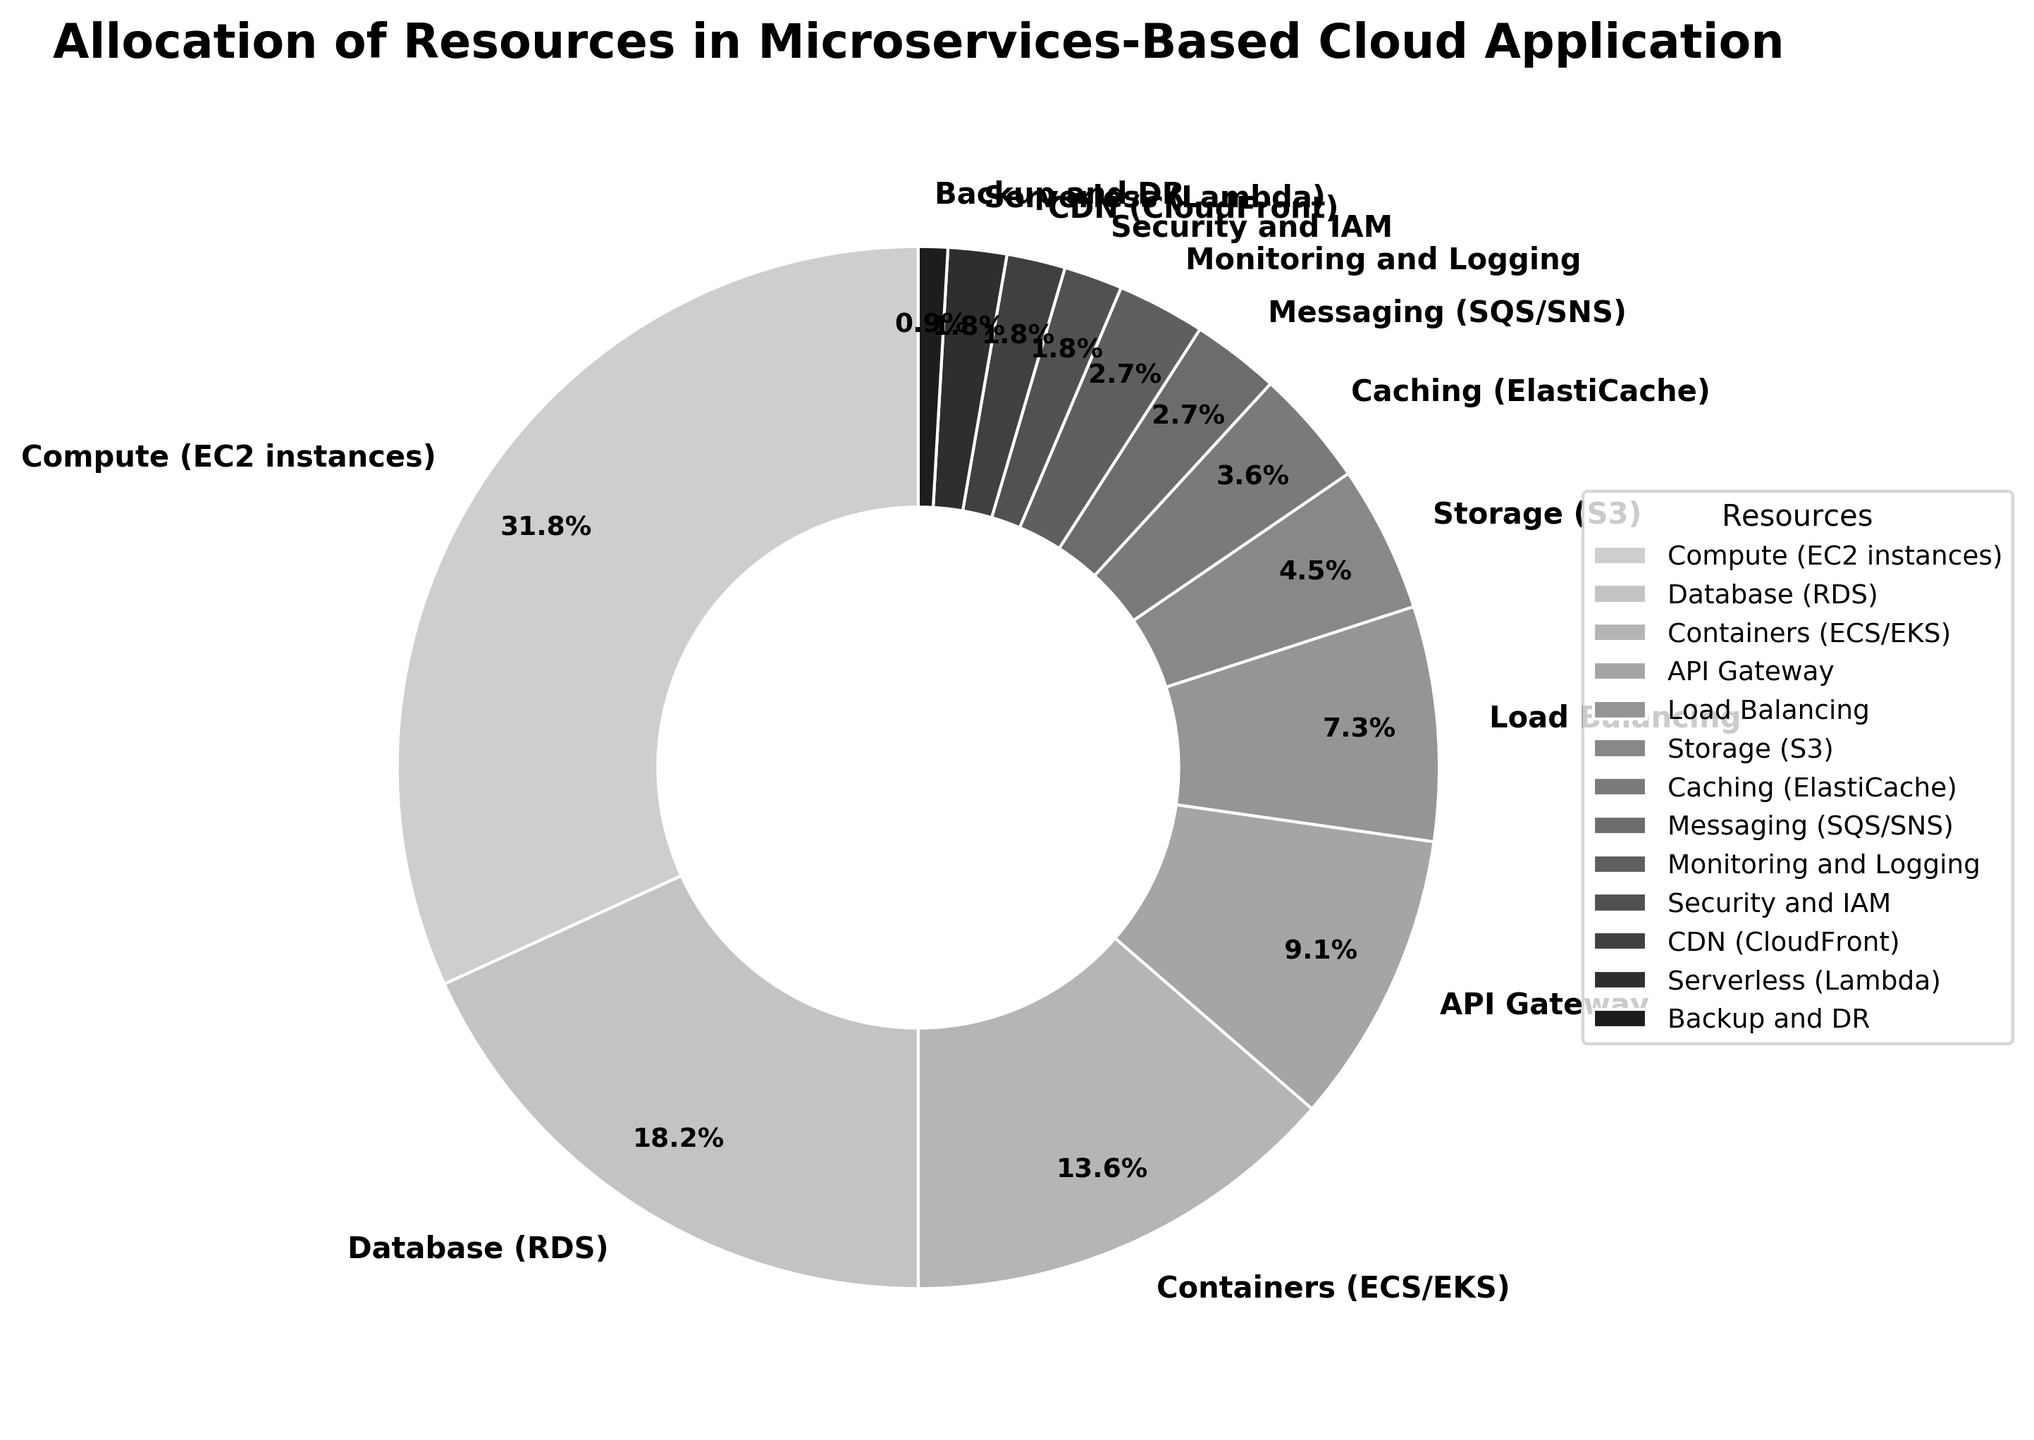What resource consumes the highest percentage of the total allocation? The pie chart shows the allocation of resources with labels indicating percentages. The segment labeled "Compute (EC2 instances)" shows the highest percentage at 35%.
Answer: Compute (EC2 instances) Which two resources together make up 20% of the allocation? To find the resources that together make up 20% of the allocation, look for individual segments that add up to 20%. Both "Messaging (SQS/SNS)" at 3% and "Monitoring and Logging" at 3% add up to 6%. Including "Caching (ElastiCache)" at 4% gives us 10%. Adding "Storage (S3)" at 5% gives 15%, and finally adding the "API Gateway" at 10% makes it 25%. Therefore, "Database (RDS)" at 20% alone contributes to 20%.
Answer: Database (RDS) How much more does Compute (EC2 instances) consume compared to Containers (ECS/EKS)? Compute (EC2 instances) consumes 35%, and Containers (ECS/EKS) consume 15%. The difference is calculated by subtracting 15% from 35%, resulting in 20%.
Answer: 20% Which resource contributes the least to the allocation? The pie chart shows various percentages for each resource, with the smallest segment labeled "Backup and DR" at 1%.
Answer: Backup and DR What is the combined percentage of Load Balancing and API Gateway? Locate the segments for Load Balancing (8%) and API Gateway (10%) and sum these percentages: 8% + 10% equals 18%.
Answer: 18% Are there more resources allocated to Load Balancing or to CDN (CloudFront) and Serverless (Lambda) combined? Load Balancing has an allocation of 8%, while both CDN (CloudFront) and Serverless (Lambda) have allocations of 2% each. Summing these, 2% + 2% equals 4%, which is less than the Load Balancing allocation of 8%.
Answer: Load Balancing What is the second least allocated resource? The pie chart shows the percentages for each resource. "Backup and DR" has the least at 1%, followed by "Security and IAM," "CDN (CloudFront)," and "Serverless (Lambda)" all at 2%. Therefore, there are multiple second least allocated resources tied at 2%.
Answer: Security and IAM, CDN (CloudFront), Serverless (Lambda) What fraction of the total allocation is allocated to Storage (S3)? Storage (S3) has a percentage allocation of 5%. This can be converted into a fraction of the total allocation by writing 5% as 5/100, which simplifies to 1/20.
Answer: 1/20 What is the summed allocation of all resources except Compute (EC2 instances) and Database (RDS)? Excluding "Compute (EC2 instances)" at 35% and "Database (RDS)" at 20%, sum the percentages of the remaining resources: 15% + 10% + 8% + 5% + 4% + 3% + 3% + 2% + 2% + 2% + 1% equals 55%. This is the total allocation for all resources other than Compute and Database.
Answer: 55% 